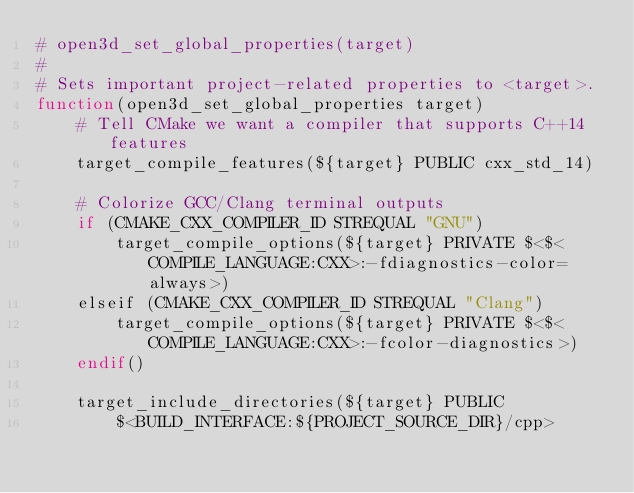Convert code to text. <code><loc_0><loc_0><loc_500><loc_500><_CMake_># open3d_set_global_properties(target)
#
# Sets important project-related properties to <target>.
function(open3d_set_global_properties target)
    # Tell CMake we want a compiler that supports C++14 features
    target_compile_features(${target} PUBLIC cxx_std_14)

    # Colorize GCC/Clang terminal outputs
    if (CMAKE_CXX_COMPILER_ID STREQUAL "GNU")
        target_compile_options(${target} PRIVATE $<$<COMPILE_LANGUAGE:CXX>:-fdiagnostics-color=always>)
    elseif (CMAKE_CXX_COMPILER_ID STREQUAL "Clang")
        target_compile_options(${target} PRIVATE $<$<COMPILE_LANGUAGE:CXX>:-fcolor-diagnostics>)
    endif()

    target_include_directories(${target} PUBLIC
        $<BUILD_INTERFACE:${PROJECT_SOURCE_DIR}/cpp></code> 